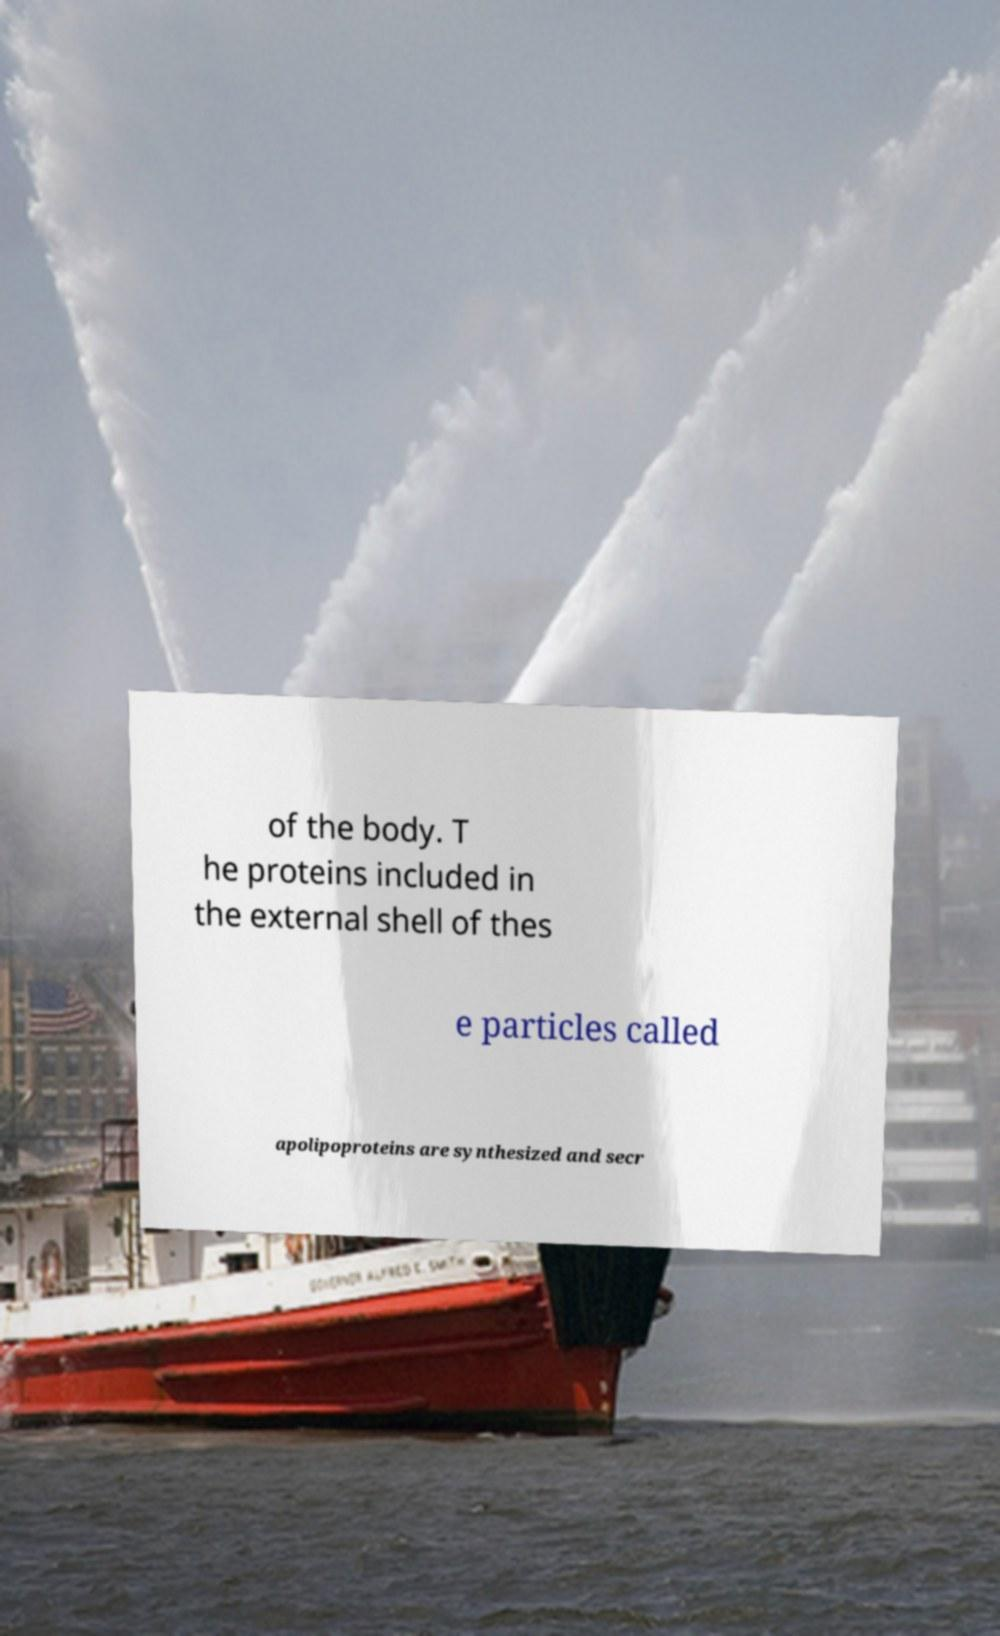For documentation purposes, I need the text within this image transcribed. Could you provide that? of the body. T he proteins included in the external shell of thes e particles called apolipoproteins are synthesized and secr 